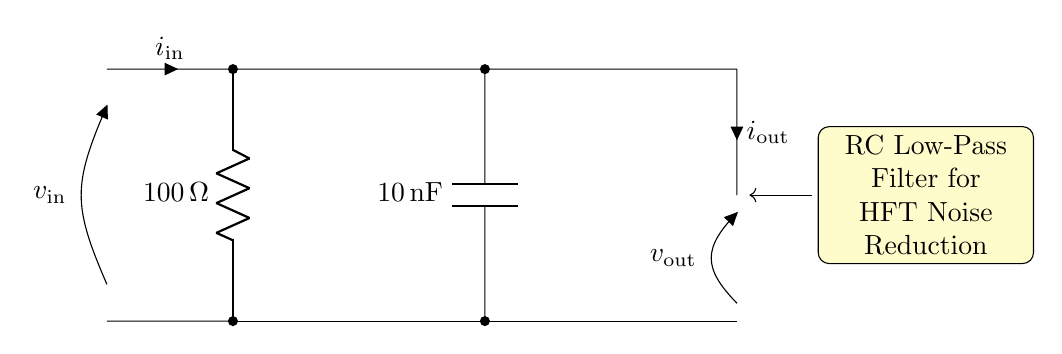What is the value of the resistor in the circuit? The resistor is labeled as R with a value of 100 ohms, which is shown directly in the diagram.
Answer: 100 ohms What type of capacitor is used in this circuit? The capacitor is labeled as C, and it has a value of 10 nanofarads, indicated in the diagram.
Answer: 10 nanofarads What is the function of this circuit? The circuit functions as a low-pass filter, designed to reduce high-frequency noise, which is explicitly mentioned in the description included in the diagram.
Answer: Low-pass filter What is the output current labeled as in the circuit? The circuit labels the output current as i_out, which provides clarity regarding its direction and nature of current flow.
Answer: i_out Why is this circuit used in high-frequency trading systems? This circuit is effective for filtering out high-frequency noise, which can interfere with signal integrity in trading systems, ensuring smooth operation and better data quality for trades.
Answer: Noise reduction What happens to the high-frequency signals at the output? In a low-pass filter like this one, high-frequency signals are significantly attenuated, meaning they lose strength and get filtered out, leading to a cleaner output signal.
Answer: They are attenuated What is the input current labeled as in the circuit? The circuit labels the input current as i_in, which indicates where the current enters the circuit for processing.
Answer: i_in 